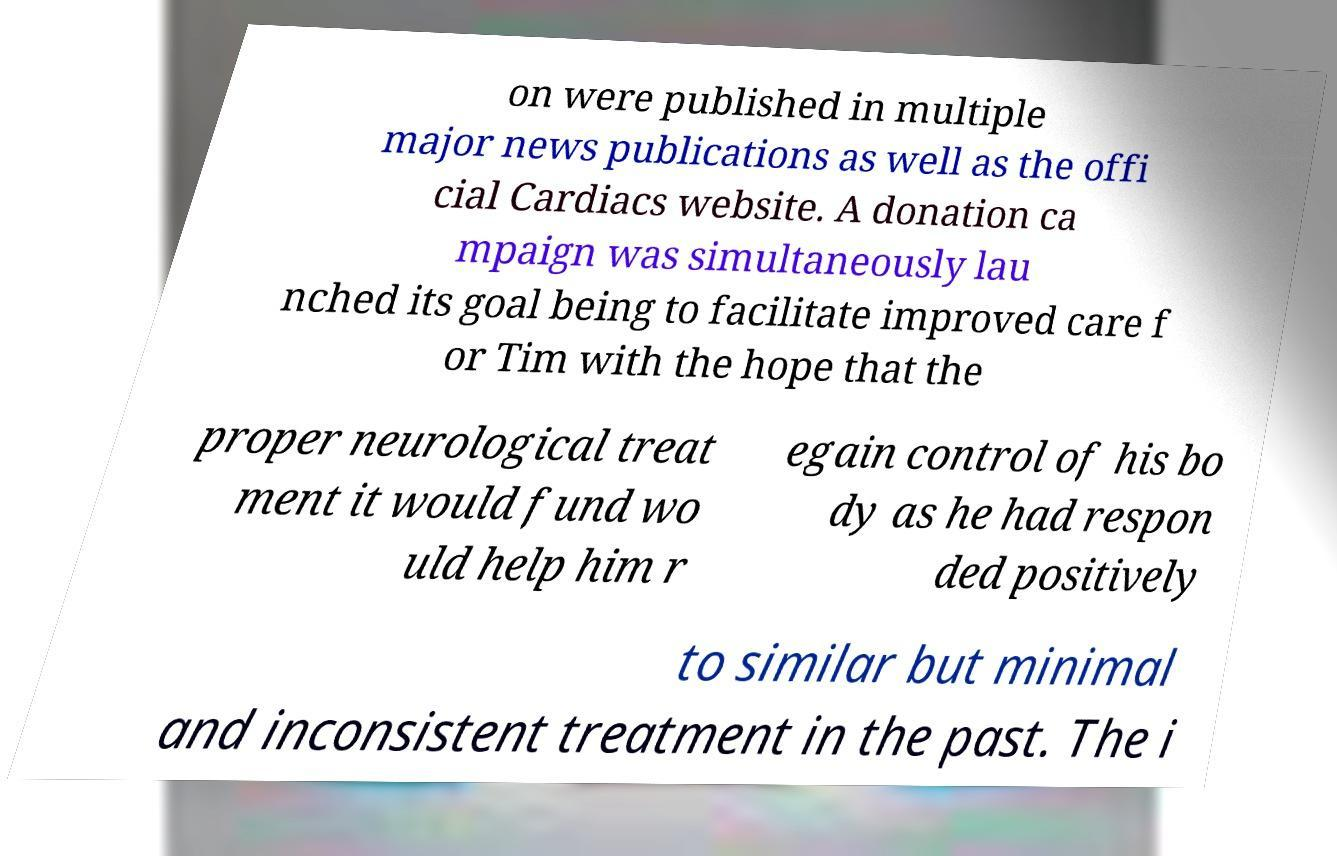What messages or text are displayed in this image? I need them in a readable, typed format. on were published in multiple major news publications as well as the offi cial Cardiacs website. A donation ca mpaign was simultaneously lau nched its goal being to facilitate improved care f or Tim with the hope that the proper neurological treat ment it would fund wo uld help him r egain control of his bo dy as he had respon ded positively to similar but minimal and inconsistent treatment in the past. The i 